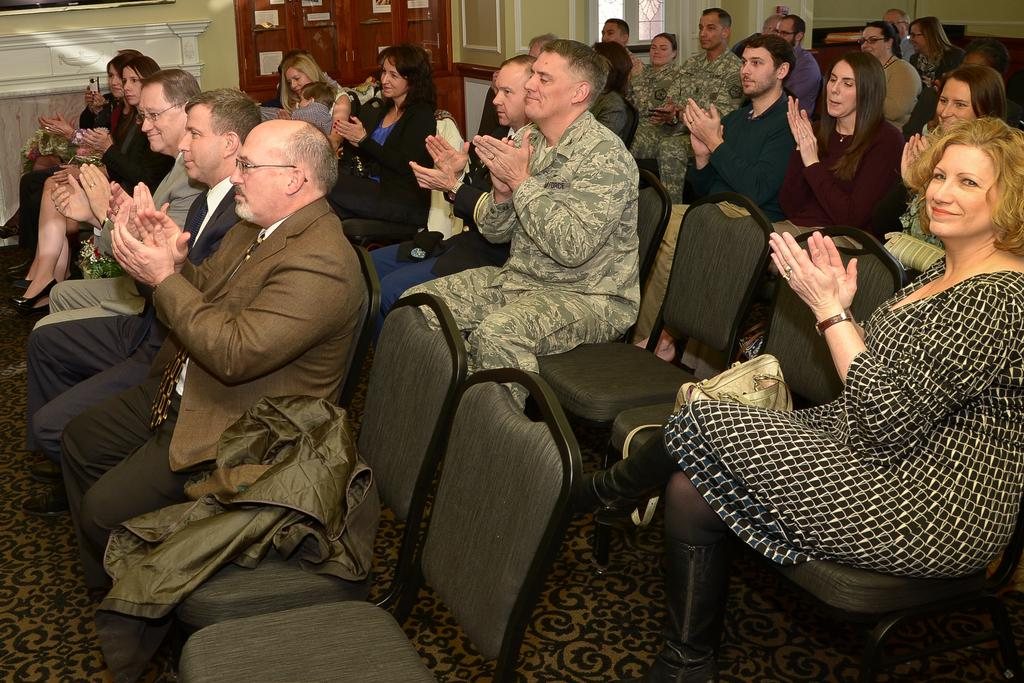What is the main subject of the image? The main subject of the image is a group of people. What are the people in the image doing? The people are sitting on chairs. How many bags of sand can be seen in the image? There are no bags of sand present in the image. Are the people in the image sleeping? The image does not show the people sleeping; they are sitting on chairs. 